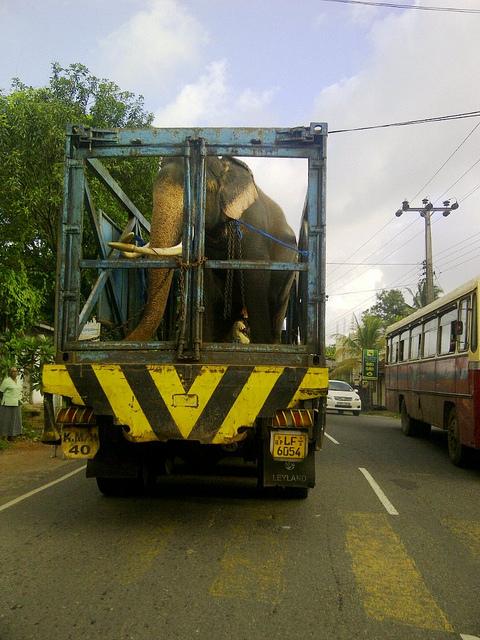What color is the back of the truck?
Quick response, please. Yellow. What is the truck transporting?
Answer briefly. Elephant. Are those cars?
Quick response, please. No. Do you think this is America?
Write a very short answer. No. 